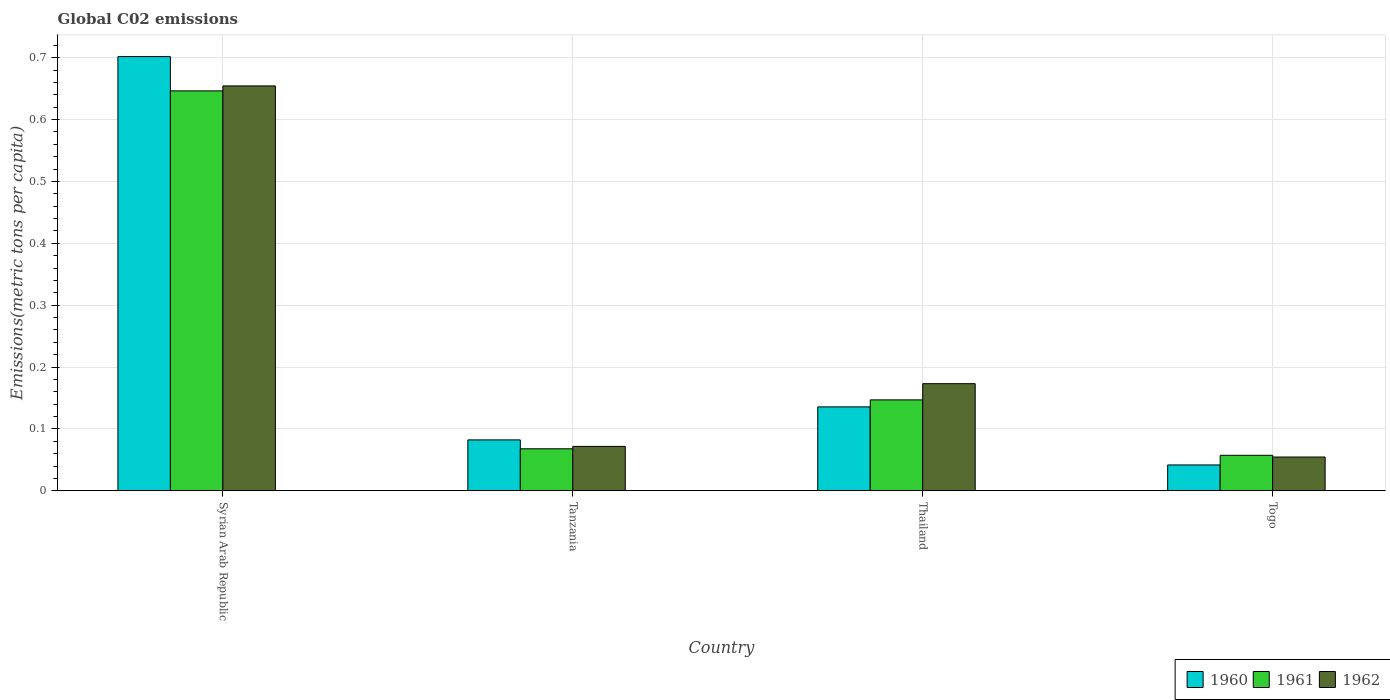Are the number of bars per tick equal to the number of legend labels?
Give a very brief answer. Yes. How many bars are there on the 4th tick from the left?
Your answer should be very brief. 3. How many bars are there on the 3rd tick from the right?
Keep it short and to the point. 3. What is the label of the 3rd group of bars from the left?
Give a very brief answer. Thailand. What is the amount of CO2 emitted in in 1961 in Togo?
Keep it short and to the point. 0.06. Across all countries, what is the maximum amount of CO2 emitted in in 1962?
Keep it short and to the point. 0.65. Across all countries, what is the minimum amount of CO2 emitted in in 1960?
Offer a terse response. 0.04. In which country was the amount of CO2 emitted in in 1961 maximum?
Provide a short and direct response. Syrian Arab Republic. In which country was the amount of CO2 emitted in in 1960 minimum?
Offer a very short reply. Togo. What is the total amount of CO2 emitted in in 1961 in the graph?
Your answer should be very brief. 0.92. What is the difference between the amount of CO2 emitted in in 1962 in Thailand and that in Togo?
Provide a short and direct response. 0.12. What is the difference between the amount of CO2 emitted in in 1961 in Thailand and the amount of CO2 emitted in in 1960 in Tanzania?
Make the answer very short. 0.06. What is the average amount of CO2 emitted in in 1960 per country?
Your answer should be very brief. 0.24. What is the difference between the amount of CO2 emitted in of/in 1962 and amount of CO2 emitted in of/in 1960 in Thailand?
Give a very brief answer. 0.04. In how many countries, is the amount of CO2 emitted in in 1960 greater than 0.04 metric tons per capita?
Ensure brevity in your answer.  4. What is the ratio of the amount of CO2 emitted in in 1960 in Tanzania to that in Thailand?
Your response must be concise. 0.61. Is the difference between the amount of CO2 emitted in in 1962 in Syrian Arab Republic and Thailand greater than the difference between the amount of CO2 emitted in in 1960 in Syrian Arab Republic and Thailand?
Provide a short and direct response. No. What is the difference between the highest and the second highest amount of CO2 emitted in in 1960?
Provide a short and direct response. 0.62. What is the difference between the highest and the lowest amount of CO2 emitted in in 1960?
Provide a succinct answer. 0.66. What does the 2nd bar from the left in Thailand represents?
Your response must be concise. 1961. What does the 3rd bar from the right in Tanzania represents?
Offer a terse response. 1960. How many bars are there?
Ensure brevity in your answer.  12. Does the graph contain any zero values?
Provide a short and direct response. No. Does the graph contain grids?
Give a very brief answer. Yes. Where does the legend appear in the graph?
Ensure brevity in your answer.  Bottom right. How many legend labels are there?
Make the answer very short. 3. How are the legend labels stacked?
Offer a very short reply. Horizontal. What is the title of the graph?
Your answer should be compact. Global C02 emissions. What is the label or title of the X-axis?
Offer a terse response. Country. What is the label or title of the Y-axis?
Offer a very short reply. Emissions(metric tons per capita). What is the Emissions(metric tons per capita) in 1960 in Syrian Arab Republic?
Offer a very short reply. 0.7. What is the Emissions(metric tons per capita) in 1961 in Syrian Arab Republic?
Provide a short and direct response. 0.65. What is the Emissions(metric tons per capita) in 1962 in Syrian Arab Republic?
Ensure brevity in your answer.  0.65. What is the Emissions(metric tons per capita) of 1960 in Tanzania?
Provide a succinct answer. 0.08. What is the Emissions(metric tons per capita) of 1961 in Tanzania?
Provide a short and direct response. 0.07. What is the Emissions(metric tons per capita) in 1962 in Tanzania?
Make the answer very short. 0.07. What is the Emissions(metric tons per capita) in 1960 in Thailand?
Ensure brevity in your answer.  0.14. What is the Emissions(metric tons per capita) of 1961 in Thailand?
Provide a succinct answer. 0.15. What is the Emissions(metric tons per capita) of 1962 in Thailand?
Offer a very short reply. 0.17. What is the Emissions(metric tons per capita) in 1960 in Togo?
Your response must be concise. 0.04. What is the Emissions(metric tons per capita) of 1961 in Togo?
Your answer should be very brief. 0.06. What is the Emissions(metric tons per capita) of 1962 in Togo?
Give a very brief answer. 0.05. Across all countries, what is the maximum Emissions(metric tons per capita) of 1960?
Give a very brief answer. 0.7. Across all countries, what is the maximum Emissions(metric tons per capita) of 1961?
Offer a very short reply. 0.65. Across all countries, what is the maximum Emissions(metric tons per capita) of 1962?
Offer a terse response. 0.65. Across all countries, what is the minimum Emissions(metric tons per capita) of 1960?
Ensure brevity in your answer.  0.04. Across all countries, what is the minimum Emissions(metric tons per capita) in 1961?
Make the answer very short. 0.06. Across all countries, what is the minimum Emissions(metric tons per capita) in 1962?
Your answer should be compact. 0.05. What is the total Emissions(metric tons per capita) in 1960 in the graph?
Give a very brief answer. 0.96. What is the total Emissions(metric tons per capita) of 1961 in the graph?
Make the answer very short. 0.92. What is the total Emissions(metric tons per capita) of 1962 in the graph?
Your answer should be compact. 0.95. What is the difference between the Emissions(metric tons per capita) in 1960 in Syrian Arab Republic and that in Tanzania?
Offer a terse response. 0.62. What is the difference between the Emissions(metric tons per capita) in 1961 in Syrian Arab Republic and that in Tanzania?
Offer a very short reply. 0.58. What is the difference between the Emissions(metric tons per capita) of 1962 in Syrian Arab Republic and that in Tanzania?
Provide a short and direct response. 0.58. What is the difference between the Emissions(metric tons per capita) in 1960 in Syrian Arab Republic and that in Thailand?
Offer a terse response. 0.57. What is the difference between the Emissions(metric tons per capita) of 1961 in Syrian Arab Republic and that in Thailand?
Make the answer very short. 0.5. What is the difference between the Emissions(metric tons per capita) of 1962 in Syrian Arab Republic and that in Thailand?
Make the answer very short. 0.48. What is the difference between the Emissions(metric tons per capita) in 1960 in Syrian Arab Republic and that in Togo?
Ensure brevity in your answer.  0.66. What is the difference between the Emissions(metric tons per capita) of 1961 in Syrian Arab Republic and that in Togo?
Provide a short and direct response. 0.59. What is the difference between the Emissions(metric tons per capita) in 1962 in Syrian Arab Republic and that in Togo?
Offer a terse response. 0.6. What is the difference between the Emissions(metric tons per capita) in 1960 in Tanzania and that in Thailand?
Offer a very short reply. -0.05. What is the difference between the Emissions(metric tons per capita) in 1961 in Tanzania and that in Thailand?
Your answer should be compact. -0.08. What is the difference between the Emissions(metric tons per capita) in 1962 in Tanzania and that in Thailand?
Ensure brevity in your answer.  -0.1. What is the difference between the Emissions(metric tons per capita) in 1960 in Tanzania and that in Togo?
Provide a short and direct response. 0.04. What is the difference between the Emissions(metric tons per capita) of 1961 in Tanzania and that in Togo?
Offer a very short reply. 0.01. What is the difference between the Emissions(metric tons per capita) in 1962 in Tanzania and that in Togo?
Keep it short and to the point. 0.02. What is the difference between the Emissions(metric tons per capita) in 1960 in Thailand and that in Togo?
Keep it short and to the point. 0.09. What is the difference between the Emissions(metric tons per capita) in 1961 in Thailand and that in Togo?
Make the answer very short. 0.09. What is the difference between the Emissions(metric tons per capita) of 1962 in Thailand and that in Togo?
Provide a short and direct response. 0.12. What is the difference between the Emissions(metric tons per capita) of 1960 in Syrian Arab Republic and the Emissions(metric tons per capita) of 1961 in Tanzania?
Make the answer very short. 0.63. What is the difference between the Emissions(metric tons per capita) of 1960 in Syrian Arab Republic and the Emissions(metric tons per capita) of 1962 in Tanzania?
Make the answer very short. 0.63. What is the difference between the Emissions(metric tons per capita) of 1961 in Syrian Arab Republic and the Emissions(metric tons per capita) of 1962 in Tanzania?
Your answer should be very brief. 0.57. What is the difference between the Emissions(metric tons per capita) of 1960 in Syrian Arab Republic and the Emissions(metric tons per capita) of 1961 in Thailand?
Your response must be concise. 0.55. What is the difference between the Emissions(metric tons per capita) of 1960 in Syrian Arab Republic and the Emissions(metric tons per capita) of 1962 in Thailand?
Ensure brevity in your answer.  0.53. What is the difference between the Emissions(metric tons per capita) in 1961 in Syrian Arab Republic and the Emissions(metric tons per capita) in 1962 in Thailand?
Make the answer very short. 0.47. What is the difference between the Emissions(metric tons per capita) in 1960 in Syrian Arab Republic and the Emissions(metric tons per capita) in 1961 in Togo?
Your answer should be very brief. 0.64. What is the difference between the Emissions(metric tons per capita) in 1960 in Syrian Arab Republic and the Emissions(metric tons per capita) in 1962 in Togo?
Offer a terse response. 0.65. What is the difference between the Emissions(metric tons per capita) of 1961 in Syrian Arab Republic and the Emissions(metric tons per capita) of 1962 in Togo?
Keep it short and to the point. 0.59. What is the difference between the Emissions(metric tons per capita) in 1960 in Tanzania and the Emissions(metric tons per capita) in 1961 in Thailand?
Give a very brief answer. -0.06. What is the difference between the Emissions(metric tons per capita) in 1960 in Tanzania and the Emissions(metric tons per capita) in 1962 in Thailand?
Your answer should be compact. -0.09. What is the difference between the Emissions(metric tons per capita) in 1961 in Tanzania and the Emissions(metric tons per capita) in 1962 in Thailand?
Offer a very short reply. -0.11. What is the difference between the Emissions(metric tons per capita) in 1960 in Tanzania and the Emissions(metric tons per capita) in 1961 in Togo?
Provide a succinct answer. 0.02. What is the difference between the Emissions(metric tons per capita) of 1960 in Tanzania and the Emissions(metric tons per capita) of 1962 in Togo?
Ensure brevity in your answer.  0.03. What is the difference between the Emissions(metric tons per capita) of 1961 in Tanzania and the Emissions(metric tons per capita) of 1962 in Togo?
Your response must be concise. 0.01. What is the difference between the Emissions(metric tons per capita) of 1960 in Thailand and the Emissions(metric tons per capita) of 1961 in Togo?
Your answer should be compact. 0.08. What is the difference between the Emissions(metric tons per capita) in 1960 in Thailand and the Emissions(metric tons per capita) in 1962 in Togo?
Keep it short and to the point. 0.08. What is the difference between the Emissions(metric tons per capita) of 1961 in Thailand and the Emissions(metric tons per capita) of 1962 in Togo?
Make the answer very short. 0.09. What is the average Emissions(metric tons per capita) in 1960 per country?
Provide a succinct answer. 0.24. What is the average Emissions(metric tons per capita) of 1961 per country?
Your answer should be compact. 0.23. What is the average Emissions(metric tons per capita) of 1962 per country?
Your answer should be very brief. 0.24. What is the difference between the Emissions(metric tons per capita) of 1960 and Emissions(metric tons per capita) of 1961 in Syrian Arab Republic?
Your response must be concise. 0.06. What is the difference between the Emissions(metric tons per capita) in 1960 and Emissions(metric tons per capita) in 1962 in Syrian Arab Republic?
Your response must be concise. 0.05. What is the difference between the Emissions(metric tons per capita) of 1961 and Emissions(metric tons per capita) of 1962 in Syrian Arab Republic?
Provide a short and direct response. -0.01. What is the difference between the Emissions(metric tons per capita) in 1960 and Emissions(metric tons per capita) in 1961 in Tanzania?
Give a very brief answer. 0.01. What is the difference between the Emissions(metric tons per capita) in 1960 and Emissions(metric tons per capita) in 1962 in Tanzania?
Provide a succinct answer. 0.01. What is the difference between the Emissions(metric tons per capita) of 1961 and Emissions(metric tons per capita) of 1962 in Tanzania?
Your answer should be very brief. -0. What is the difference between the Emissions(metric tons per capita) in 1960 and Emissions(metric tons per capita) in 1961 in Thailand?
Give a very brief answer. -0.01. What is the difference between the Emissions(metric tons per capita) of 1960 and Emissions(metric tons per capita) of 1962 in Thailand?
Your answer should be very brief. -0.04. What is the difference between the Emissions(metric tons per capita) in 1961 and Emissions(metric tons per capita) in 1962 in Thailand?
Your response must be concise. -0.03. What is the difference between the Emissions(metric tons per capita) in 1960 and Emissions(metric tons per capita) in 1961 in Togo?
Keep it short and to the point. -0.02. What is the difference between the Emissions(metric tons per capita) in 1960 and Emissions(metric tons per capita) in 1962 in Togo?
Your answer should be very brief. -0.01. What is the difference between the Emissions(metric tons per capita) of 1961 and Emissions(metric tons per capita) of 1962 in Togo?
Ensure brevity in your answer.  0. What is the ratio of the Emissions(metric tons per capita) in 1960 in Syrian Arab Republic to that in Tanzania?
Your response must be concise. 8.53. What is the ratio of the Emissions(metric tons per capita) in 1961 in Syrian Arab Republic to that in Tanzania?
Make the answer very short. 9.52. What is the ratio of the Emissions(metric tons per capita) in 1962 in Syrian Arab Republic to that in Tanzania?
Give a very brief answer. 9.12. What is the ratio of the Emissions(metric tons per capita) of 1960 in Syrian Arab Republic to that in Thailand?
Provide a succinct answer. 5.18. What is the ratio of the Emissions(metric tons per capita) in 1961 in Syrian Arab Republic to that in Thailand?
Keep it short and to the point. 4.4. What is the ratio of the Emissions(metric tons per capita) of 1962 in Syrian Arab Republic to that in Thailand?
Provide a short and direct response. 3.78. What is the ratio of the Emissions(metric tons per capita) of 1960 in Syrian Arab Republic to that in Togo?
Ensure brevity in your answer.  16.8. What is the ratio of the Emissions(metric tons per capita) of 1961 in Syrian Arab Republic to that in Togo?
Keep it short and to the point. 11.26. What is the ratio of the Emissions(metric tons per capita) of 1962 in Syrian Arab Republic to that in Togo?
Provide a succinct answer. 11.99. What is the ratio of the Emissions(metric tons per capita) in 1960 in Tanzania to that in Thailand?
Your answer should be compact. 0.61. What is the ratio of the Emissions(metric tons per capita) of 1961 in Tanzania to that in Thailand?
Provide a short and direct response. 0.46. What is the ratio of the Emissions(metric tons per capita) in 1962 in Tanzania to that in Thailand?
Provide a succinct answer. 0.41. What is the ratio of the Emissions(metric tons per capita) of 1960 in Tanzania to that in Togo?
Give a very brief answer. 1.97. What is the ratio of the Emissions(metric tons per capita) of 1961 in Tanzania to that in Togo?
Offer a very short reply. 1.18. What is the ratio of the Emissions(metric tons per capita) of 1962 in Tanzania to that in Togo?
Provide a succinct answer. 1.31. What is the ratio of the Emissions(metric tons per capita) of 1960 in Thailand to that in Togo?
Keep it short and to the point. 3.25. What is the ratio of the Emissions(metric tons per capita) in 1961 in Thailand to that in Togo?
Your response must be concise. 2.56. What is the ratio of the Emissions(metric tons per capita) in 1962 in Thailand to that in Togo?
Provide a succinct answer. 3.17. What is the difference between the highest and the second highest Emissions(metric tons per capita) in 1960?
Make the answer very short. 0.57. What is the difference between the highest and the second highest Emissions(metric tons per capita) in 1961?
Your response must be concise. 0.5. What is the difference between the highest and the second highest Emissions(metric tons per capita) in 1962?
Your answer should be very brief. 0.48. What is the difference between the highest and the lowest Emissions(metric tons per capita) of 1960?
Offer a very short reply. 0.66. What is the difference between the highest and the lowest Emissions(metric tons per capita) in 1961?
Ensure brevity in your answer.  0.59. What is the difference between the highest and the lowest Emissions(metric tons per capita) in 1962?
Provide a short and direct response. 0.6. 